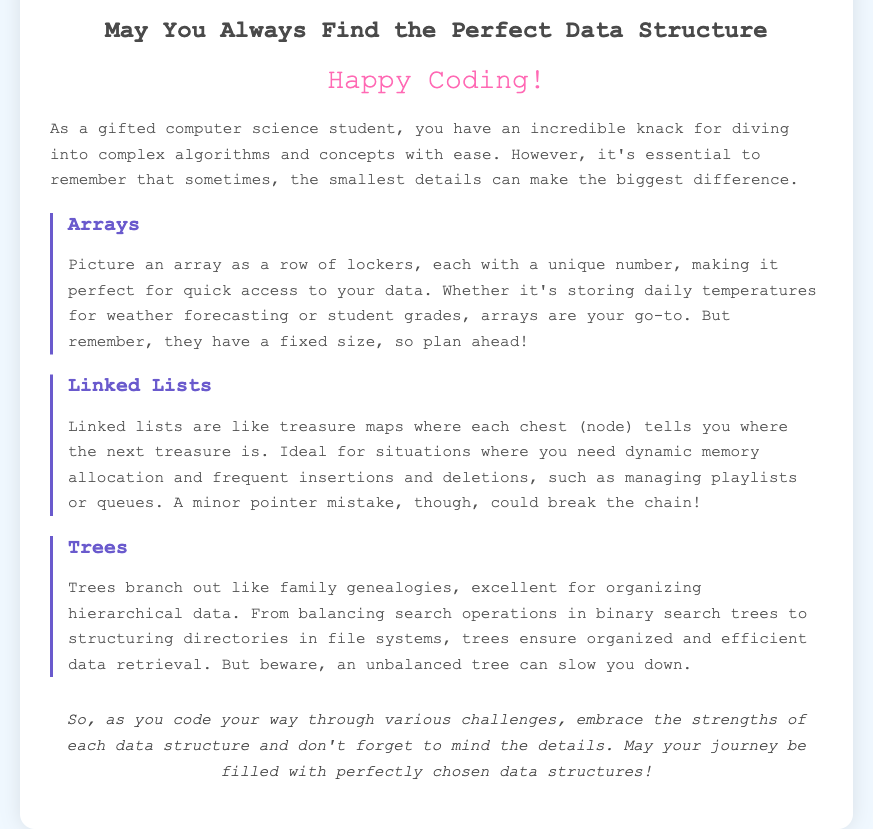What is the title of the greeting card? The title is stated at the top of the card, summarizing its main theme.
Answer: May You Always Find the Perfect Data Structure What data structure is compared to a row of lockers? The description of quick access and fixed size refers to a specific data structure in the card.
Answer: Arrays Which data structure is described as "like treasure maps"? This data structure is illustrated with imagery of navigation and connections.
Answer: Linked Lists What color is the "Happy Coding!" text? The color of this prominent greeting adds visual appeal to the card.
Answer: Pink Which data structure is said to be excellent for organizing hierarchical data? The functions of a particular data structure are highlighted in the context of organization.
Answer: Trees What should you remember when using arrays according to the card? The guidance provided in relation to the limitations of this data structure is crucial.
Answer: Fixed size What kind of mistake could break the chain in linked lists? The potential for error in this data structure is noted in the context of pointers.
Answer: Pointer mistake What is emphasized as important in the journey of coding according to the card? The overall message of the card encourages a mindset important for programming.
Answer: Attention to detail 